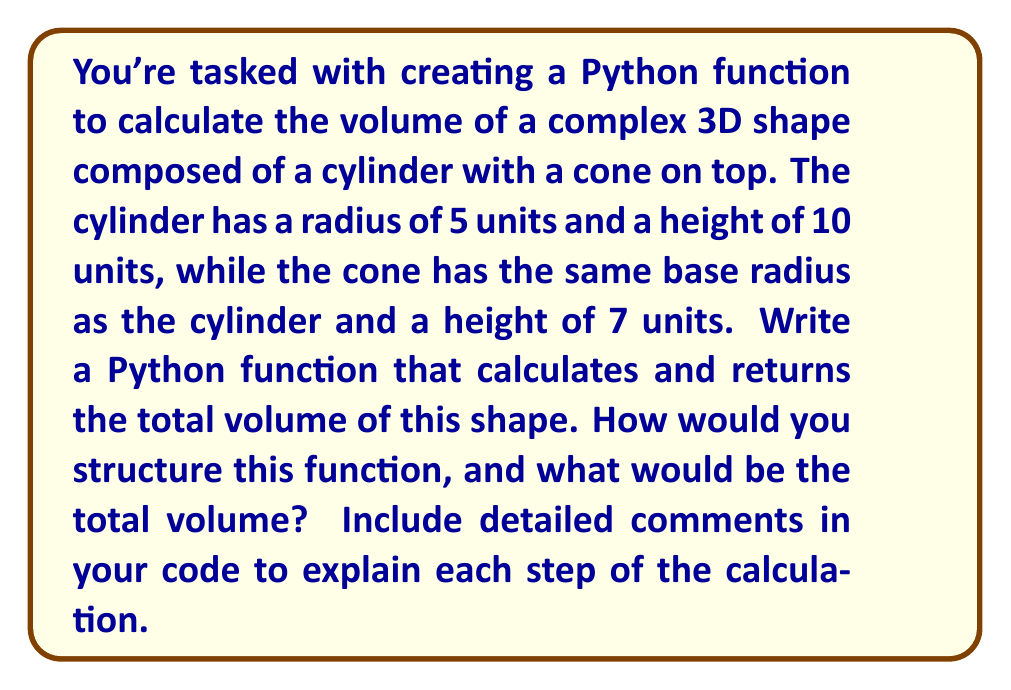Help me with this question. To solve this problem, we need to break it down into steps:

1. Calculate the volume of the cylinder:
   The volume of a cylinder is given by the formula:
   $$V_{cylinder} = \pi r^2 h$$
   where $r$ is the radius and $h$ is the height.

2. Calculate the volume of the cone:
   The volume of a cone is given by the formula:
   $$V_{cone} = \frac{1}{3} \pi r^2 h$$
   where $r$ is the radius of the base and $h$ is the height.

3. Sum the volumes to get the total volume.

Here's a Python function with detailed comments that implements this solution:

```python
import math

def calculate_complex_shape_volume(cylinder_radius, cylinder_height, cone_height):
    """
    Calculate the volume of a complex 3D shape composed of a cylinder with a cone on top.
    
    Args:
    cylinder_radius (float): The radius of the cylinder and the base of the cone.
    cylinder_height (float): The height of the cylinder.
    cone_height (float): The height of the cone.
    
    Returns:
    float: The total volume of the complex shape.
    """
    # Calculate the volume of the cylinder
    cylinder_volume = math.pi * cylinder_radius**2 * cylinder_height
    
    # Calculate the volume of the cone
    cone_volume = (1/3) * math.pi * cylinder_radius**2 * cone_height
    
    # Calculate the total volume by summing the cylinder and cone volumes
    total_volume = cylinder_volume + cone_volume
    
    return total_volume

# Calculate the volume with the given dimensions
result = calculate_complex_shape_volume(5, 10, 7)
print(f"The total volume of the complex shape is {result:.2f} cubic units.")
```

Now, let's calculate the volume:

1. Cylinder volume:
   $$V_{cylinder} = \pi * 5^2 * 10 = 250\pi \approx 785.40$$

2. Cone volume:
   $$V_{cone} = \frac{1}{3} * \pi * 5^2 * 7 = \frac{175\pi}{3} \approx 183.26$$

3. Total volume:
   $$V_{total} = V_{cylinder} + V_{cone} = 250\pi + \frac{175\pi}{3} = \frac{925\pi}{3} \approx 968.66$$

The Python function will return this value when called with the given dimensions.
Answer: The total volume of the complex 3D shape is approximately 968.66 cubic units. 